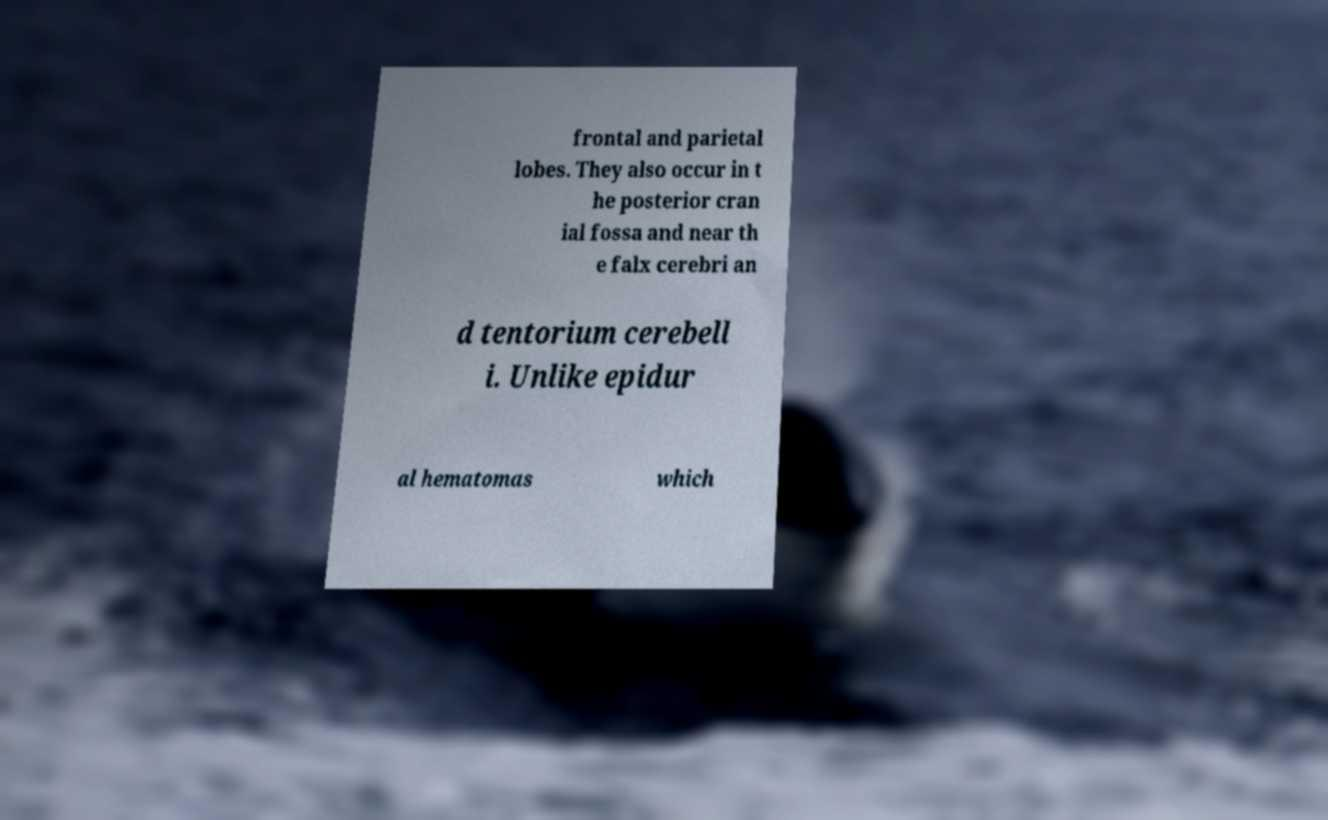For documentation purposes, I need the text within this image transcribed. Could you provide that? frontal and parietal lobes. They also occur in t he posterior cran ial fossa and near th e falx cerebri an d tentorium cerebell i. Unlike epidur al hematomas which 